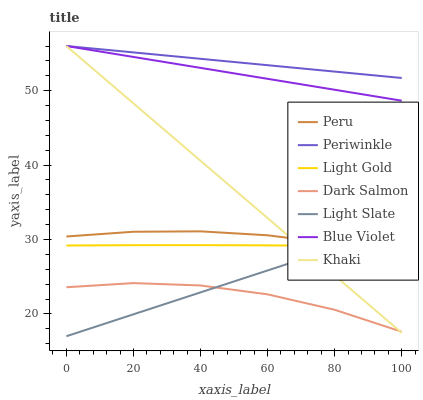Does Dark Salmon have the minimum area under the curve?
Answer yes or no. Yes. Does Periwinkle have the maximum area under the curve?
Answer yes or no. Yes. Does Light Slate have the minimum area under the curve?
Answer yes or no. No. Does Light Slate have the maximum area under the curve?
Answer yes or no. No. Is Light Slate the smoothest?
Answer yes or no. Yes. Is Dark Salmon the roughest?
Answer yes or no. Yes. Is Dark Salmon the smoothest?
Answer yes or no. No. Is Light Slate the roughest?
Answer yes or no. No. Does Light Slate have the lowest value?
Answer yes or no. Yes. Does Dark Salmon have the lowest value?
Answer yes or no. No. Does Blue Violet have the highest value?
Answer yes or no. Yes. Does Light Slate have the highest value?
Answer yes or no. No. Is Light Slate less than Blue Violet?
Answer yes or no. Yes. Is Blue Violet greater than Dark Salmon?
Answer yes or no. Yes. Does Light Gold intersect Khaki?
Answer yes or no. Yes. Is Light Gold less than Khaki?
Answer yes or no. No. Is Light Gold greater than Khaki?
Answer yes or no. No. Does Light Slate intersect Blue Violet?
Answer yes or no. No. 